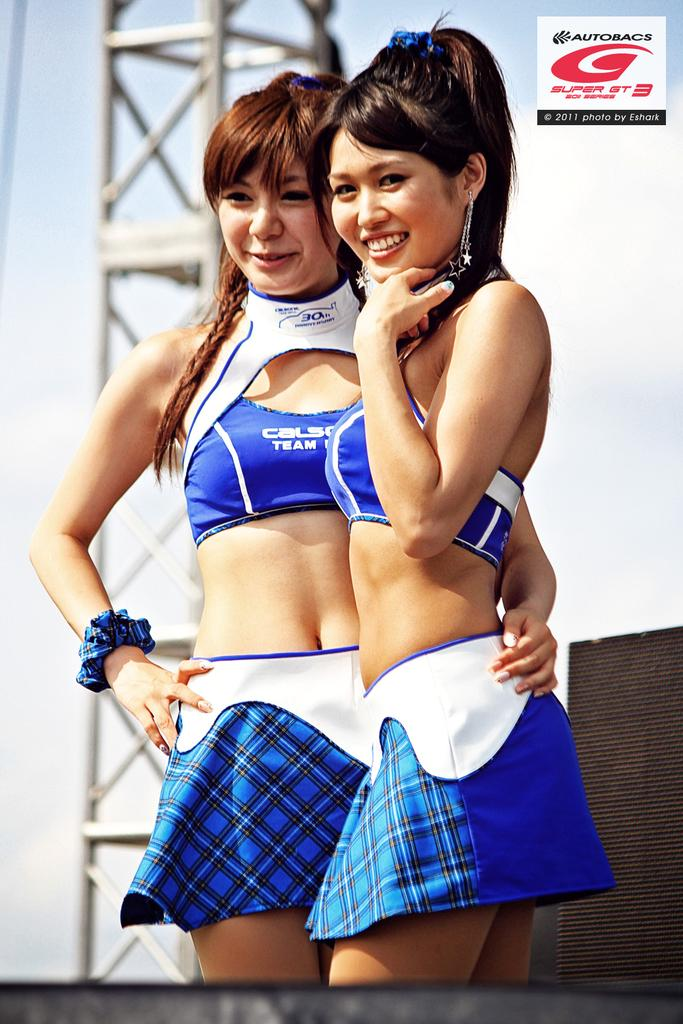<image>
Share a concise interpretation of the image provided. A picture of two women taken by Eshark at Autobacs 